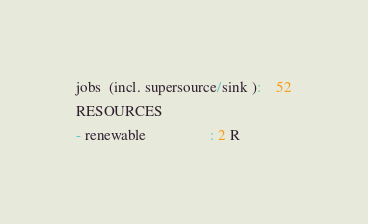Convert code to text. <code><loc_0><loc_0><loc_500><loc_500><_ObjectiveC_>jobs  (incl. supersource/sink ):	52
RESOURCES
- renewable                 : 2 R</code> 